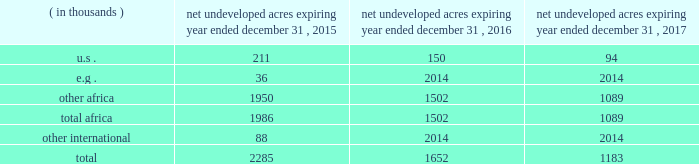In the ordinary course of business , based on our evaluations of certain geologic trends and prospective economics , we have allowed certain lease acreage to expire and may allow additional acreage to expire in the future .
If production is not established or we take no other action to extend the terms of the leases , licenses , or concessions , undeveloped acreage listed in the table below will expire over the next three years .
We plan to continue the terms of many of these licenses and concession areas or retain leases through operational or administrative actions .
Net undeveloped acres expiring year ended december 31 .
Oil sands mining segment we hold a 20 percent non-operated interest in the aosp , an oil sands mining and upgrading joint venture located in alberta , canada .
The joint venture produces bitumen from oil sands deposits in the athabasca region utilizing mining techniques and upgrades the bitumen to synthetic crude oils and vacuum gas oil .
The aosp 2019s mining and extraction assets are located near fort mcmurray , alberta , and include the muskeg river and the jackpine mines .
Gross design capacity of the combined mines is 255000 ( 51000 net to our interest ) barrels of bitumen per day .
The aosp operations use established processes to mine oil sands deposits from an open-pit mine , extract the bitumen and upgrade it into synthetic crude oils .
Ore is mined using traditional truck and shovel mining techniques .
The mined ore passes through primary crushers to reduce the ore chunks in size and is then sent to rotary breakers where the ore chunks are further reduced to smaller particles .
The particles are combined with hot water to create slurry .
The slurry moves through the extraction process where it separates into sand , clay and bitumen-rich froth .
A solvent is added to the bitumen froth to separate out the remaining solids , water and heavy asphaltenes .
The solvent washes the sand and produces clean bitumen that is required for the upgrader to run efficiently .
The process yields a mixture of solvent and bitumen which is then transported from the mine to the scotford upgrader via the approximately 300-mile corridor pipeline .
The aosp's scotford upgrader is located at fort saskatchewan , northeast of edmonton , alberta .
The bitumen is upgraded at scotford using both hydrotreating and hydroconversion processes to remove sulfur and break the heavy bitumen molecules into lighter products .
Blendstocks acquired from outside sources are utilized in the production of our saleable products .
The upgrader produces synthetic crude oils and vacuum gas oil .
The vacuum gas oil is sold to an affiliate of the operator under a long-term contract at market-related prices , and the other products are sold in the marketplace .
As of december 31 , 2014 , we own or have rights to participate in developed and undeveloped leases totaling approximately 163000 gross ( 33000 net ) acres .
The underlying developed leases are held for the duration of the project , with royalties payable to the province of alberta .
Synthetic crude oil sales volumes for 2014 averaged 50 mbbld and net-of-royalty production was 41 mbbld .
In december 2013 , a jackpine mine expansion project received conditional approval from the canadian government .
The project includes additional mining areas , associated processing facilities and infrastructure .
The government conditions relate to wildlife , the environment and aboriginal health issues .
We will evaluate the potential expansion project and government conditions after infrastructure reliability initiatives are completed .
The governments of alberta and canada have agreed to partially fund quest ccs for $ 865 million canadian .
In the third quarter of 2012 , the energy and resources conservation board ( "ercb" ) , alberta's primary energy regulator at that time , conditionally approved the project and the aosp partners approved proceeding to construct and operate quest ccs .
Government funding commenced in 2012 and continued as milestones were achieved during the development , construction and operating phases .
Failure of the aosp to meet certain timing , performance and operating objectives may result in repaying some of the government funding .
Construction and commissioning of quest ccs is expected to be completed by late 2015. .
By how much did net undeveloped acres decrease from 2015 to 2016? 
Computations: ((2285 - 1652) / 2285)
Answer: 0.27702. 